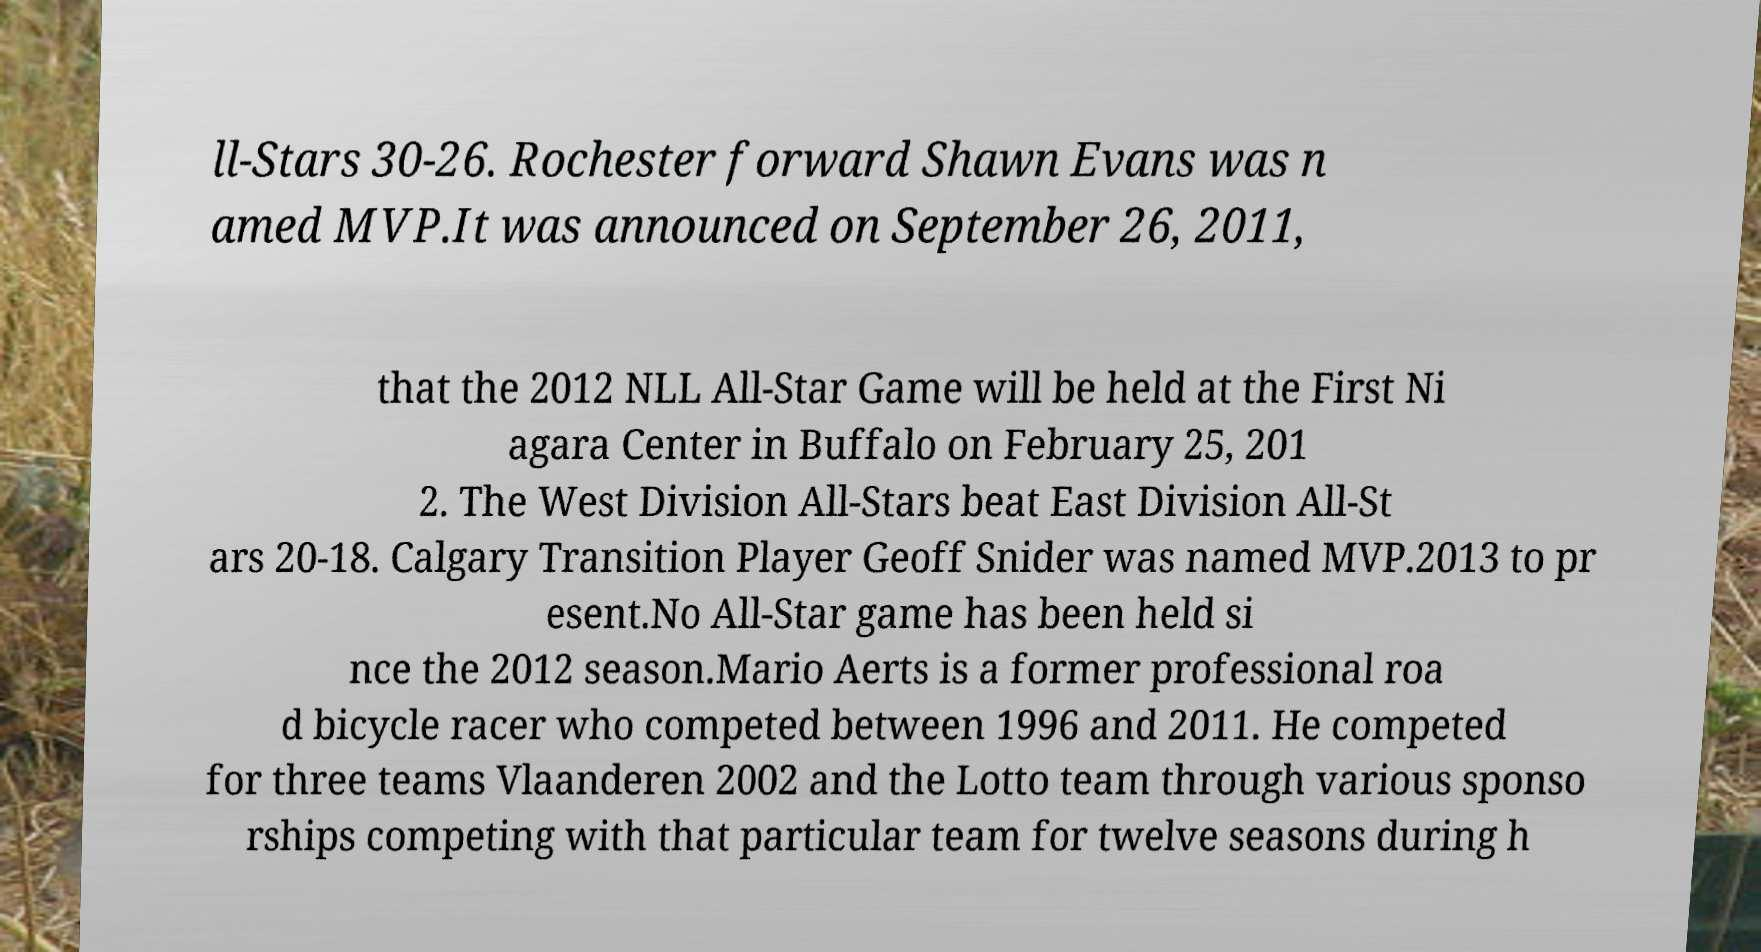For documentation purposes, I need the text within this image transcribed. Could you provide that? ll-Stars 30-26. Rochester forward Shawn Evans was n amed MVP.It was announced on September 26, 2011, that the 2012 NLL All-Star Game will be held at the First Ni agara Center in Buffalo on February 25, 201 2. The West Division All-Stars beat East Division All-St ars 20-18. Calgary Transition Player Geoff Snider was named MVP.2013 to pr esent.No All-Star game has been held si nce the 2012 season.Mario Aerts is a former professional roa d bicycle racer who competed between 1996 and 2011. He competed for three teams Vlaanderen 2002 and the Lotto team through various sponso rships competing with that particular team for twelve seasons during h 